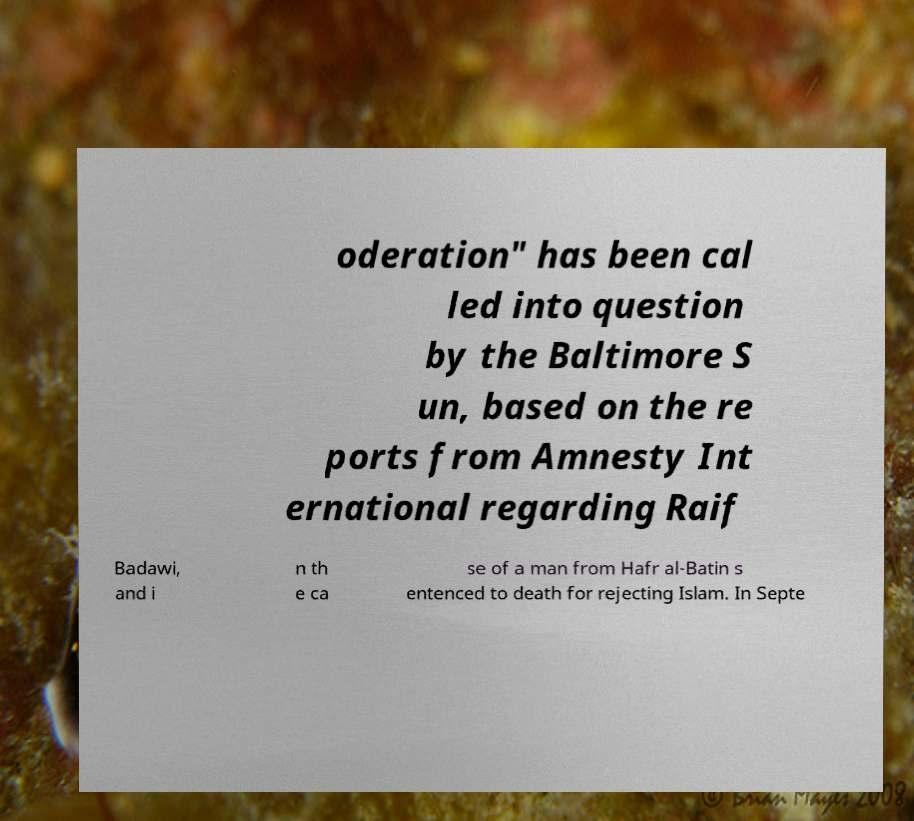There's text embedded in this image that I need extracted. Can you transcribe it verbatim? oderation" has been cal led into question by the Baltimore S un, based on the re ports from Amnesty Int ernational regarding Raif Badawi, and i n th e ca se of a man from Hafr al-Batin s entenced to death for rejecting Islam. In Septe 